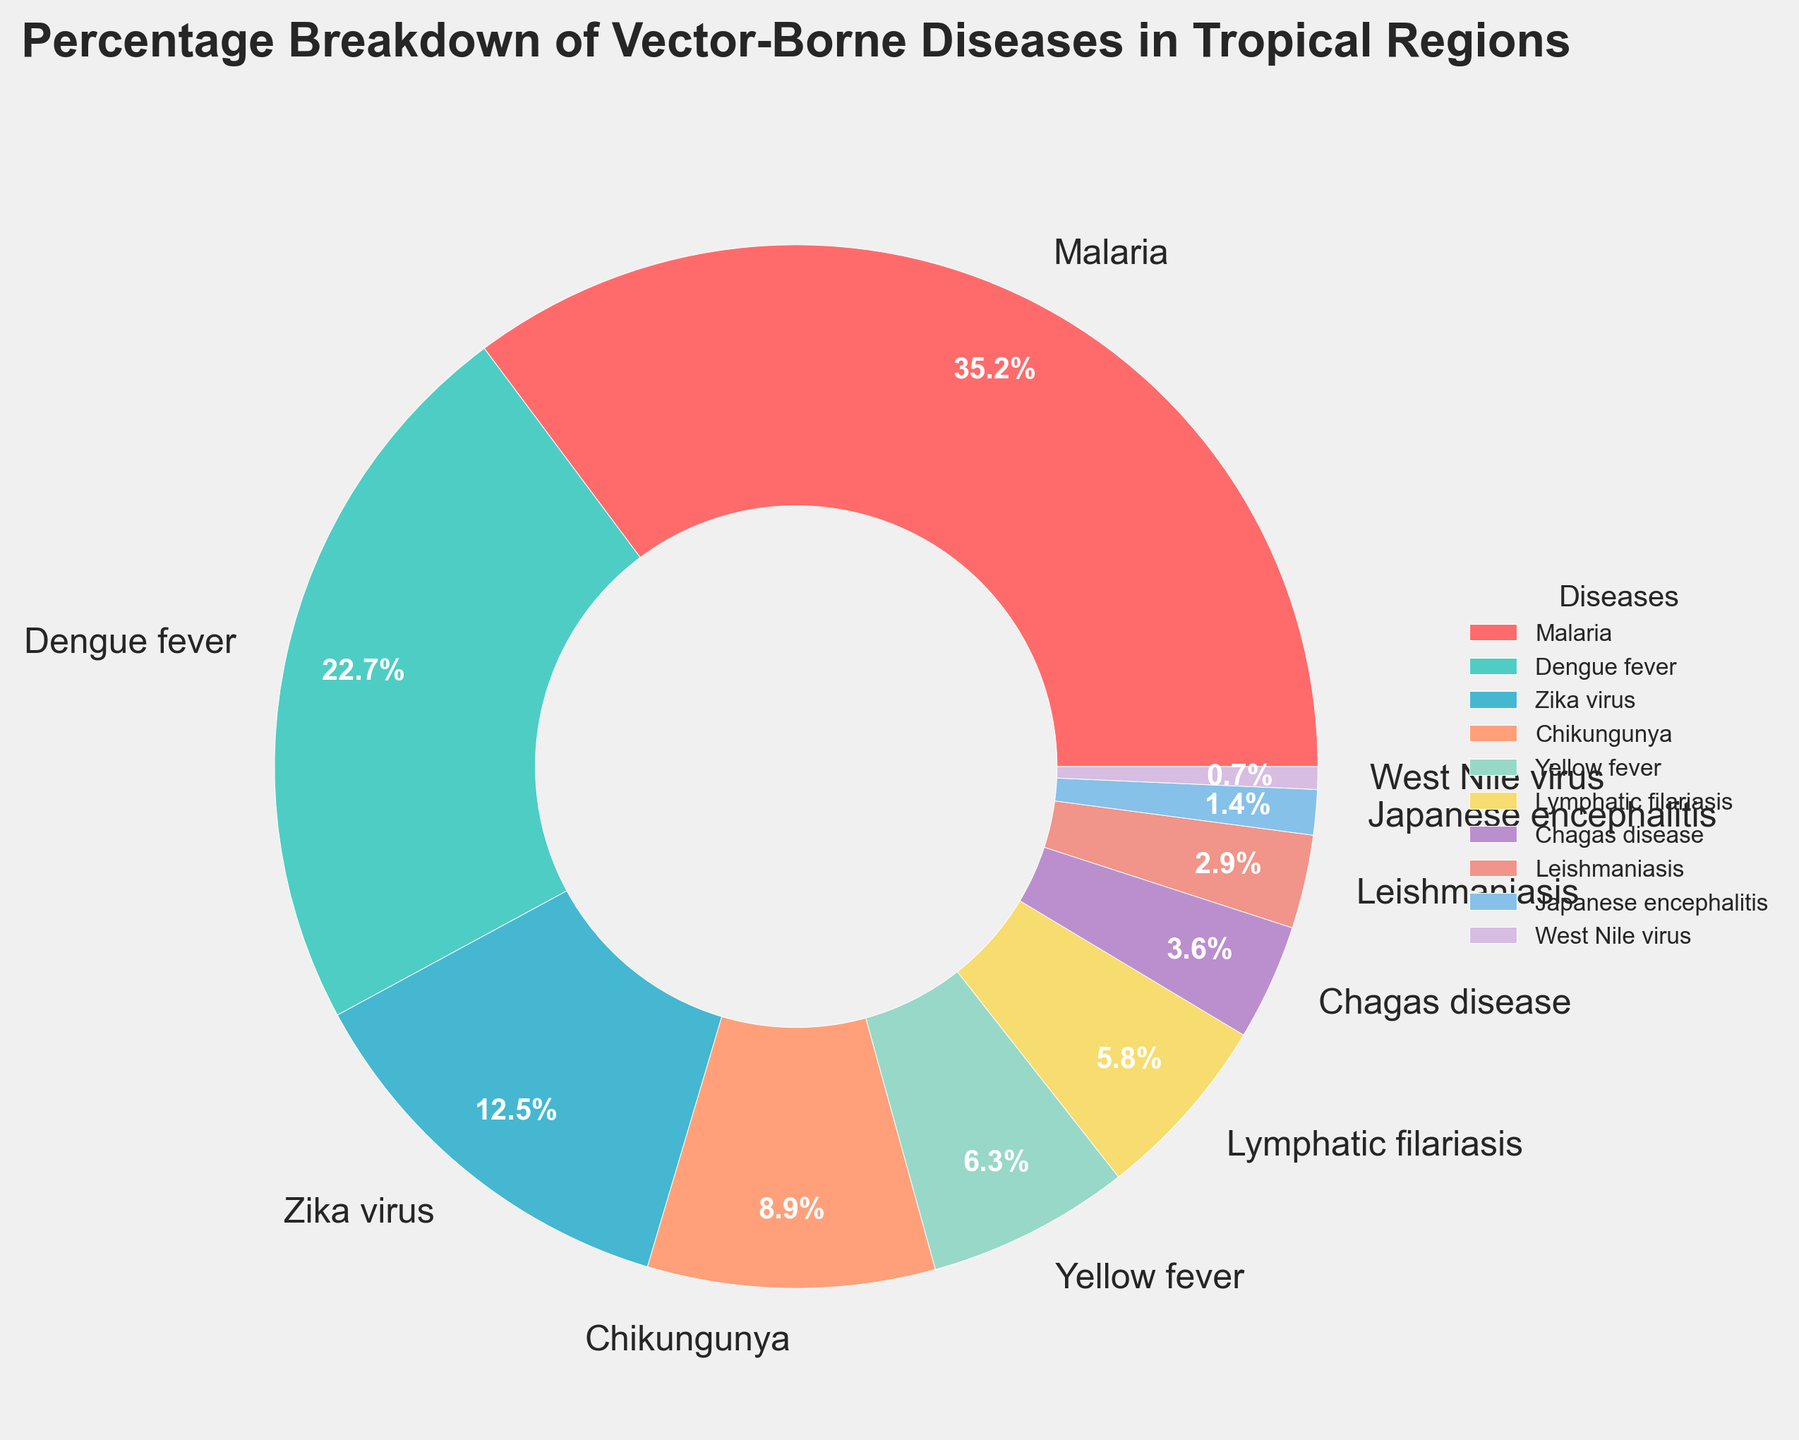Which disease has the largest percentage in the pie chart? The disease with the largest percentage can be identified by finding the label with the highest value on the figure. Malaria has a percentage of 35.2%, which is the highest.
Answer: Malaria What is the combined percentage of Dengue fever and Zika virus? To find the combined percentage, sum the individual percentages of Dengue fever and Zika virus. Dengue fever has 22.7% and Zika virus has 12.5%. 22.7 + 12.5 = 35.2%
Answer: 35.2% Which disease has the smallest percentage in the pie chart? The disease with the smallest percentage can be identified by finding the label with the lowest value on the figure. West Nile virus has 0.7%, which is the lowest.
Answer: West Nile virus How much greater is the percentage of Malaria than Chikungunya? To find how much greater Malaria's percentage is compared to Chikungunya, subtract Chikungunya's percentage from Malaria's. Malaria has 35.2% and Chikungunya has 8.9%. 35.2 - 8.9 = 26.3%
Answer: 26.3% What is the total percentage contributed by all diseases classified together as "others" having less than 4% each? To find the total percentage of diseases each with less than 4%, sum their individual percentages. Chagas disease (3.6%), Leishmaniasis (2.9%), Japanese encephalitis (1.4%), and West Nile virus (0.7%) all have less than 4% each. 3.6 + 2.9 + 1.4 + 0.7 = 8.6%
Answer: 8.6% Which two diseases have their combined percentage equal to the percentage of Malaria? To find the two diseases whose combined percentage is equal to Malaria's percentage (35.2%), identify pairs of values from the figure whose sum equals 35.2%. Dengue fever (22.7%) and Zika virus (12.5%) together sum up to 22.7 + 12.5 = 35.2%
Answer: Dengue fever and Zika virus Which wedge color represents Yellow fever in the pie chart? To identify the color representing Yellow fever, look for the label "Yellow fever" and observe the corresponding wedge's color in the figure. Yellow fever is represented by the wedge with a lighter shade, similar to a light mustard color.
Answer: Light mustard color What is the difference between the percentage of Dengue fever and Japanese encephalitis? To find the difference between the percentages of Dengue fever and Japanese encephalitis, subtract Japanese encephalitis's percentage from Dengue fever's. Dengue fever has 22.7% and Japanese encephalitis has 1.4%. 22.7 - 1.4 = 21.3%
Answer: 21.3% Is Lymphatic filariasis represented by a larger percentage than Yellow fever? Compare the percentages of Lymphatic filariasis and Yellow fever. Lymphatic filariasis has 5.8% and Yellow fever has 6.3%. 5.8% is not larger than 6.3%.
Answer: No Are the total percentages of Chagas disease and Leishmaniasis greater than that of Chikungunya? Sum the percentages of Chagas disease and Leishmaniasis and compare to Chikungunya's percentage. Chagas disease has 3.6%, Leishmaniasis has 2.9%, and Chikungunya has 8.9%. 3.6 + 2.9 = 6.5, which is less than 8.9.
Answer: No 